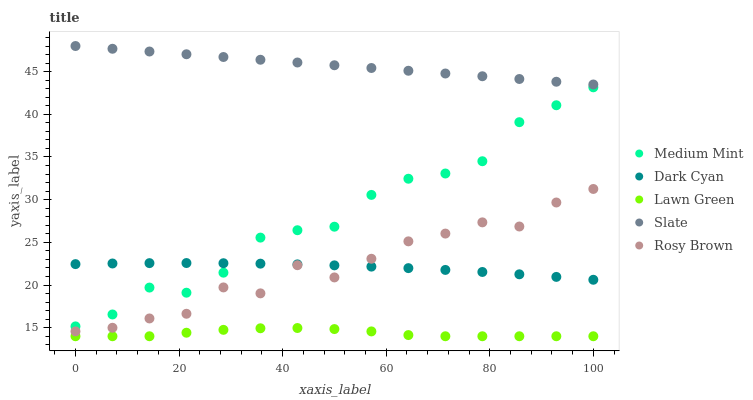Does Lawn Green have the minimum area under the curve?
Answer yes or no. Yes. Does Slate have the maximum area under the curve?
Answer yes or no. Yes. Does Dark Cyan have the minimum area under the curve?
Answer yes or no. No. Does Dark Cyan have the maximum area under the curve?
Answer yes or no. No. Is Slate the smoothest?
Answer yes or no. Yes. Is Rosy Brown the roughest?
Answer yes or no. Yes. Is Dark Cyan the smoothest?
Answer yes or no. No. Is Dark Cyan the roughest?
Answer yes or no. No. Does Lawn Green have the lowest value?
Answer yes or no. Yes. Does Dark Cyan have the lowest value?
Answer yes or no. No. Does Slate have the highest value?
Answer yes or no. Yes. Does Dark Cyan have the highest value?
Answer yes or no. No. Is Medium Mint less than Slate?
Answer yes or no. Yes. Is Rosy Brown greater than Lawn Green?
Answer yes or no. Yes. Does Rosy Brown intersect Dark Cyan?
Answer yes or no. Yes. Is Rosy Brown less than Dark Cyan?
Answer yes or no. No. Is Rosy Brown greater than Dark Cyan?
Answer yes or no. No. Does Medium Mint intersect Slate?
Answer yes or no. No. 